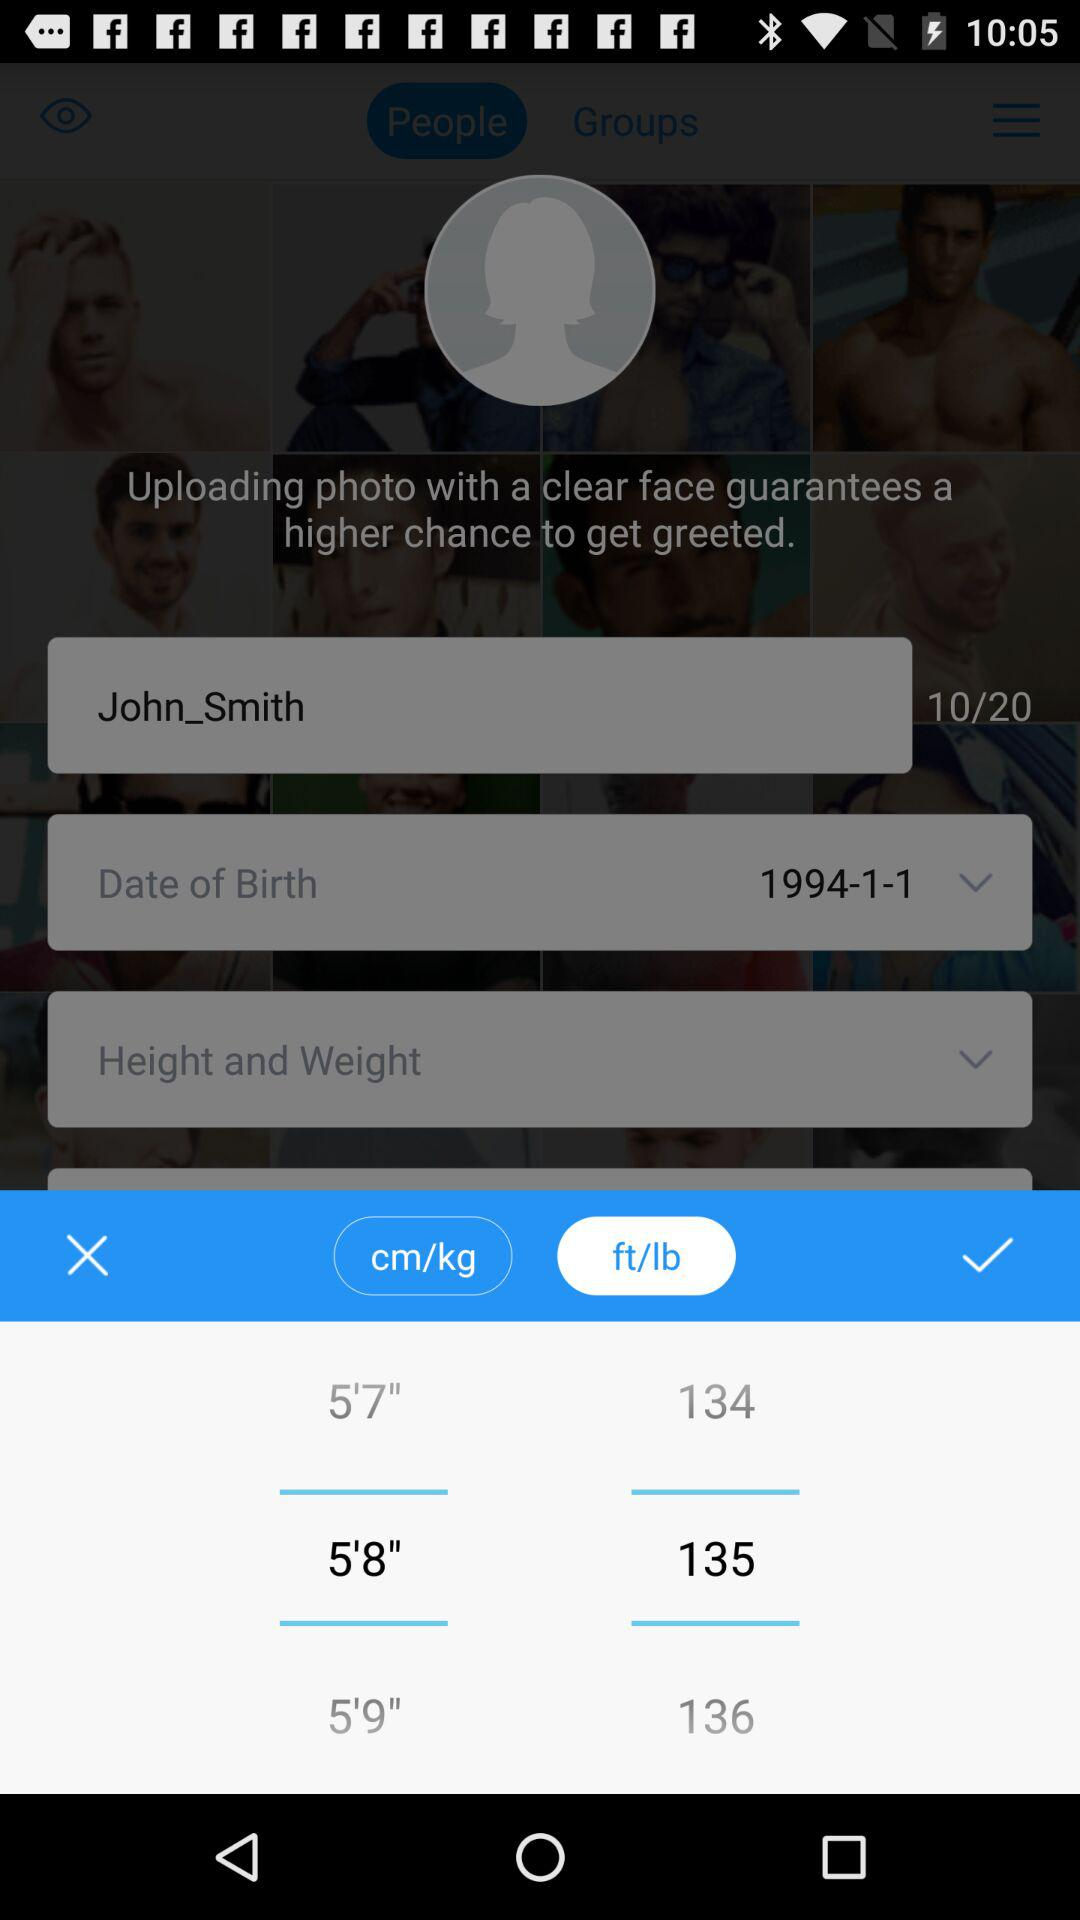What is the selected height of a person in feet? The selected height of a person is 5 feet 8 inches. 